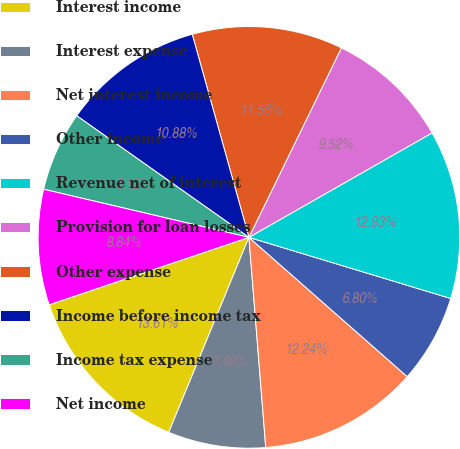<chart> <loc_0><loc_0><loc_500><loc_500><pie_chart><fcel>Interest income<fcel>Interest expense<fcel>Net interest income<fcel>Other income<fcel>Revenue net of interest<fcel>Provision for loan losses<fcel>Other expense<fcel>Income before income tax<fcel>Income tax expense<fcel>Net income<nl><fcel>13.61%<fcel>7.48%<fcel>12.24%<fcel>6.8%<fcel>12.93%<fcel>9.52%<fcel>11.56%<fcel>10.88%<fcel>6.12%<fcel>8.84%<nl></chart> 